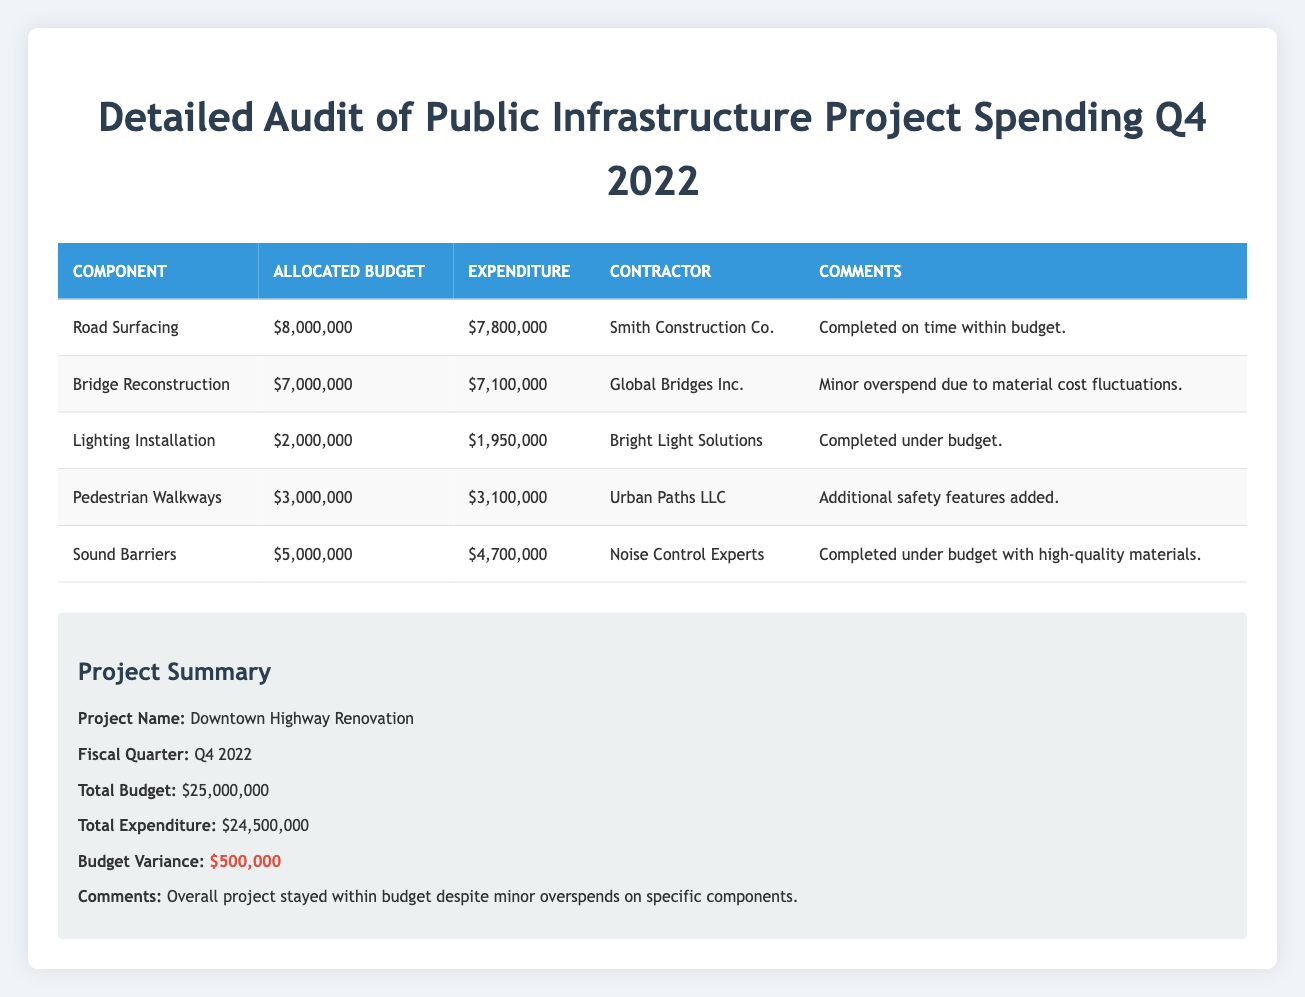What is the total budget for the Downtown Highway Renovation project? The total budget for the project is listed in the summary section of the table. It states that the total budget is $25,000,000.
Answer: 25,000,000 How much was allocated for the Road Surfacing component? The allocated budget for the Road Surfacing component can be found in the table where it states $8,000,000 as the allocated budget.
Answer: 8,000,000 Was the expenditure for Lighting Installation under budget? The expenditure for Lighting Installation is $1,950,000, while the allocated budget is $2,000,000. Since the expenditure is less than the allocated budget, it is indeed under budget.
Answer: Yes What is the budget variance for the overall project? The budget variance is calculated by subtracting the total expenditure from the total budget. Here, $25,000,000 - $24,500,000 = $500,000.
Answer: 500,000 Which component had the highest overspend and by how much? Reviewing the table, the Bridge Reconstruction component had an expenditure of $7,100,000 versus an allocated budget of $7,000,000, resulting in an overspend of $100,000. This is the highest overspend compared to the other components.
Answer: Bridge Reconstruction, 100,000 How much did the Sound Barriers component save from its allocated budget? The expenditure for the Sound Barriers component is $4,700,000 and the allocated budget is $5,000,000. To find the savings, we subtract the expenditure from the allocated budget: $5,000,000 - $4,700,000 = $300,000.
Answer: 300,000 Was the total expenditure for the project greater than the total budget? The total expenditure stated in the summary is $24,500,000, which is less than the total budget of $25,000,000. Therefore, the total expenditure was not greater than the total budget.
Answer: No What is the average expenditure per component for the Downtown Highway Renovation project? There are 5 components in the project. To find the average expenditure, we sum the expenditure values ($7,800,000 + $7,100,000 + $1,950,000 + $3,100,000 + $4,700,000 = $24,650,000) and divide by 5. The average is $24,650,000 / 5 = $4,930,000.
Answer: 4,930,000 Which contractor completed their work under budget and for which component? The completed under budget components listed are Lighting Installation (contractor Bright Light Solutions) and Sound Barriers (contractor Noise Control Experts). Both had expenditures less than their allocated budgets.
Answer: Lighting Installation, Bright Light Solutions and Sound Barriers, Noise Control Experts 